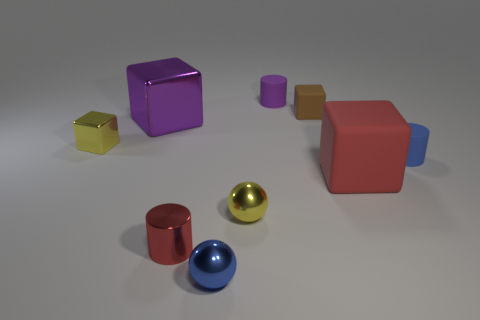Subtract all rubber cylinders. How many cylinders are left? 1 Subtract all yellow spheres. How many spheres are left? 1 Subtract 1 blocks. How many blocks are left? 3 Subtract all blocks. How many objects are left? 5 Add 1 purple things. How many objects exist? 10 Subtract 0 green cylinders. How many objects are left? 9 Subtract all red cylinders. Subtract all brown spheres. How many cylinders are left? 2 Subtract all green blocks. How many purple cylinders are left? 1 Subtract all tiny objects. Subtract all tiny blue cylinders. How many objects are left? 1 Add 2 small red cylinders. How many small red cylinders are left? 3 